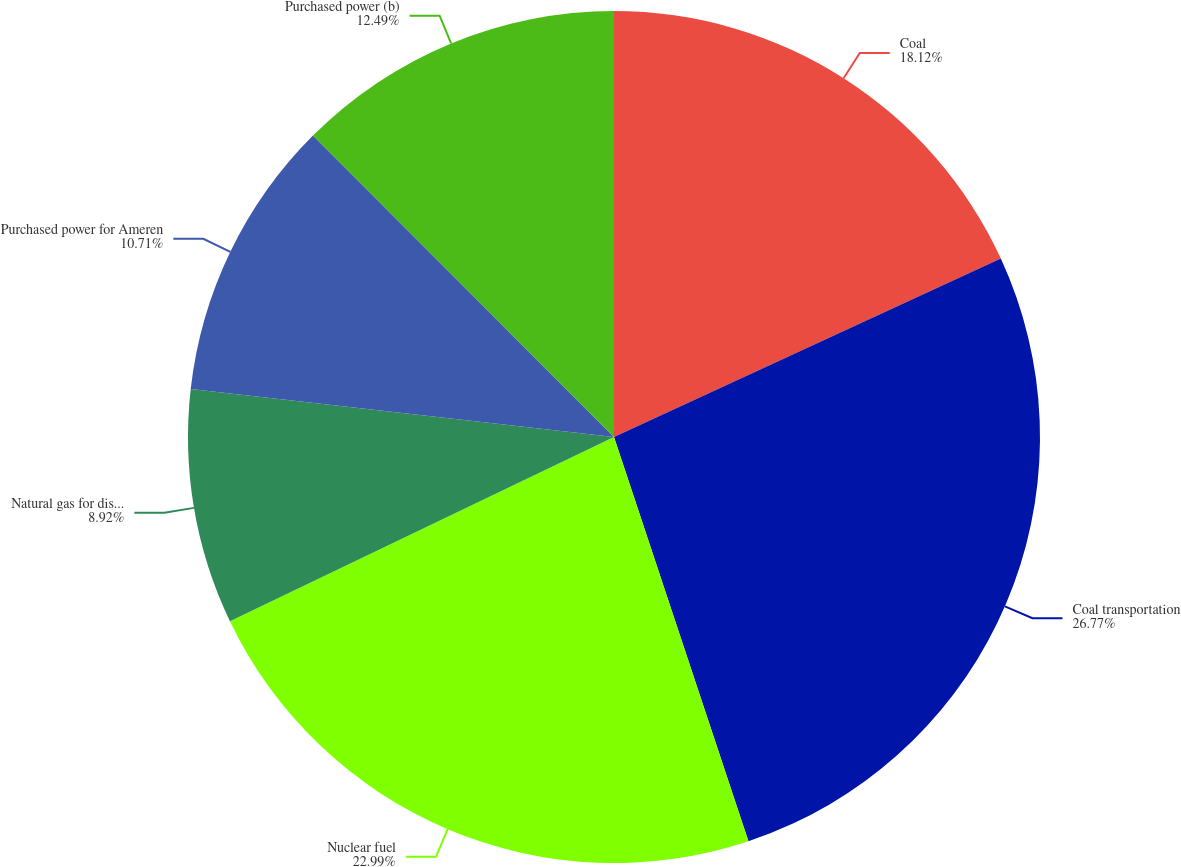Convert chart to OTSL. <chart><loc_0><loc_0><loc_500><loc_500><pie_chart><fcel>Coal<fcel>Coal transportation<fcel>Nuclear fuel<fcel>Natural gas for distribution<fcel>Purchased power for Ameren<fcel>Purchased power (b)<nl><fcel>18.12%<fcel>26.77%<fcel>22.99%<fcel>8.92%<fcel>10.71%<fcel>12.49%<nl></chart> 